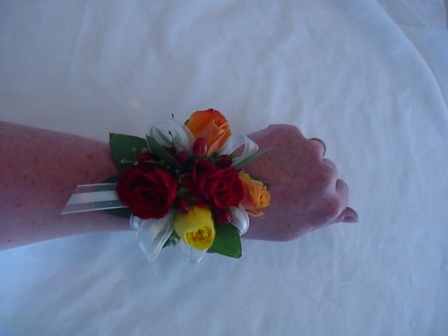Analyze the image in a comprehensive and detailed manner. In the image, a person's hand is adorned with a vibrant and elegantly crafted corsage, resting gently on what appears to be a white tablecloth. The corsage features a stunning arrangement of roses in a beautiful mix of colors: deep red, bright yellow, and vibrant orange. These roses are artfully tied together with delicate white ribbons, adding an extra touch of elegance to the arrangement. Surrounding the roses are lush green leaves, which enhance the freshness and liveliness of the corsage. The relaxed posture of the hand wearing the corsage suggests a moment of calm, possibly amidst a celebratory event such as a prom, wedding, or other special occasion where such corsages are customarily worn. The overall composition of the image evokes a sense of grace, festivity, and attention to detail. 